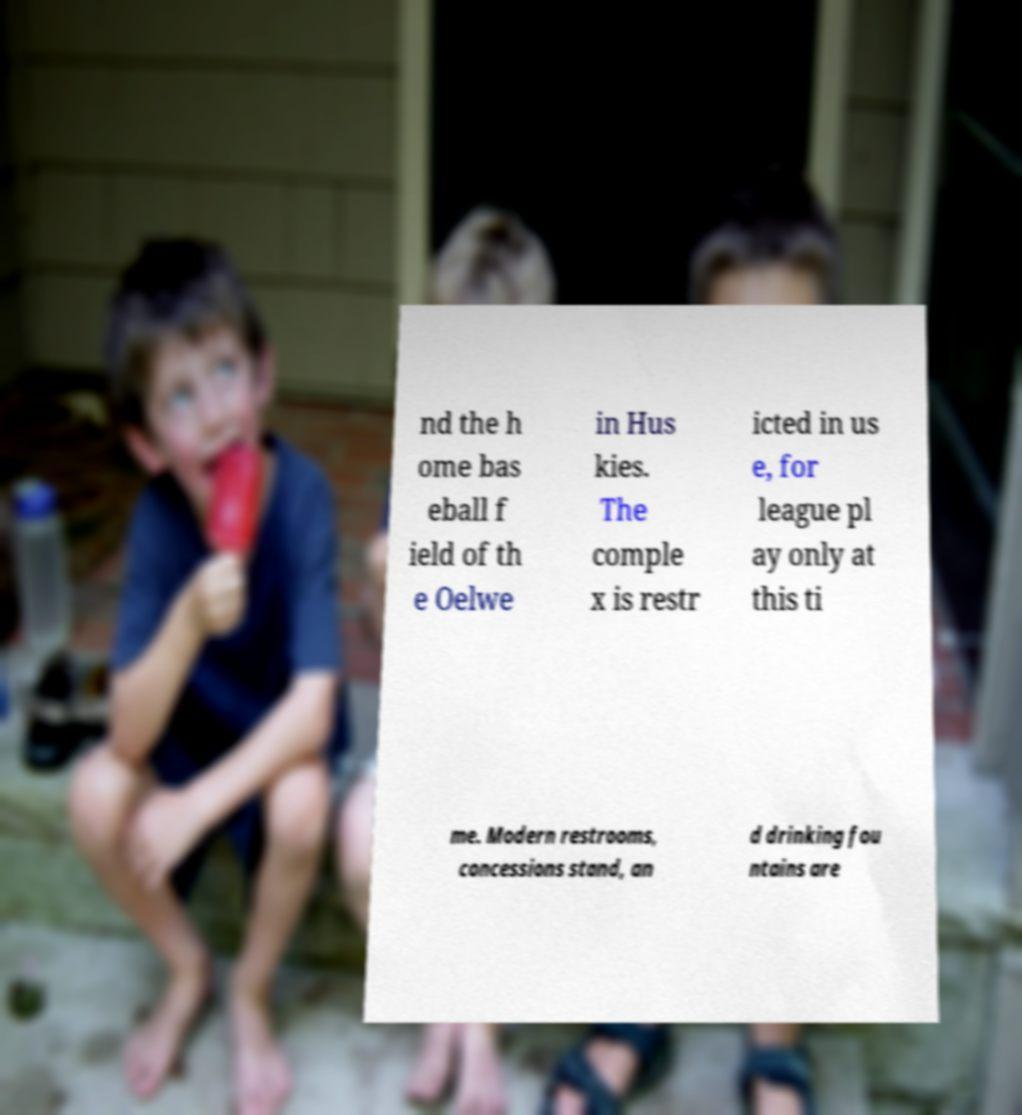Could you extract and type out the text from this image? nd the h ome bas eball f ield of th e Oelwe in Hus kies. The comple x is restr icted in us e, for league pl ay only at this ti me. Modern restrooms, concessions stand, an d drinking fou ntains are 